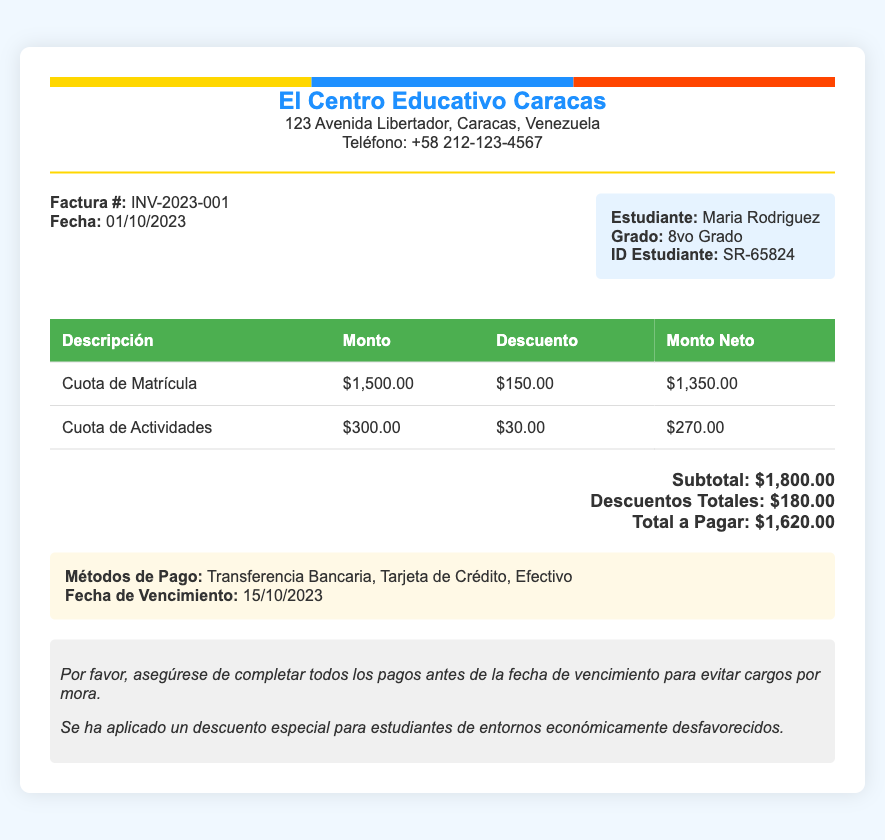What is the invoice number? The invoice number is specified under "Factura #," which is INV-2023-001.
Answer: INV-2023-001 What is the total tuition fees before discounts? The total tuition fees before discounts can be determined by adding the amounts listed for "Cuota de Matrícula" and "Cuota de Actividades," which is $1,500.00 + $300.00.
Answer: $1,800.00 What student ID is mentioned in the document? The document lists the student ID under "ID Estudiante," which is SR-65824.
Answer: SR-65824 What is the total discount applied? The total discount is found under "Descuentos Totales," which is $180.00.
Answer: $180.00 When is the payment due date? The payment due date is listed under "Fecha de Vencimiento," which is 15/10/2023.
Answer: 15/10/2023 What is the net amount for the activity fee after discount? To find the net amount for the activity fee, look under "Monto Neto" for "Cuota de Actividades," which is $270.00.
Answer: $270.00 What payment methods are accepted? Accepted payment methods can be found under "Métodos de Pago," which are Transferencia Bancaria, Tarjeta de Crédito, Efectivo.
Answer: Transferencia Bancaria, Tarjeta de Crédito, Efectivo What is the total amount to be paid after discounts? The total amount to be paid after discounts is indicated under "Total a Pagar," which is $1,620.00.
Answer: $1,620.00 What is the school’s name? The school's name is prominently displayed at the top of the document.
Answer: El Centro Educativo Caracas 